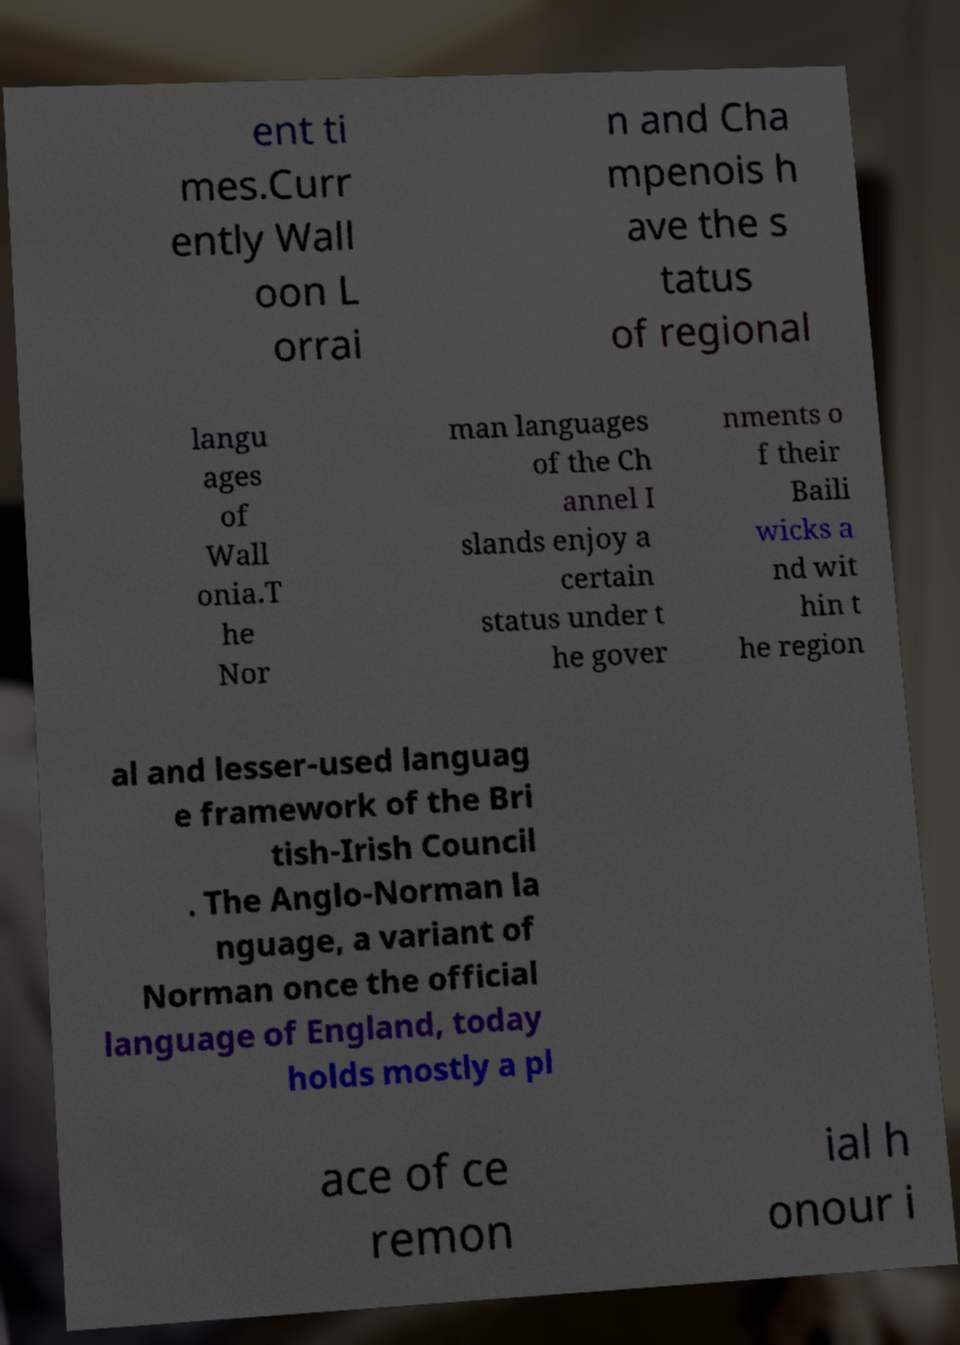What messages or text are displayed in this image? I need them in a readable, typed format. ent ti mes.Curr ently Wall oon L orrai n and Cha mpenois h ave the s tatus of regional langu ages of Wall onia.T he Nor man languages of the Ch annel I slands enjoy a certain status under t he gover nments o f their Baili wicks a nd wit hin t he region al and lesser-used languag e framework of the Bri tish-Irish Council . The Anglo-Norman la nguage, a variant of Norman once the official language of England, today holds mostly a pl ace of ce remon ial h onour i 